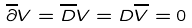<formula> <loc_0><loc_0><loc_500><loc_500>\overline { \partial } V = \overline { D } V = D \overline { V } = 0</formula> 